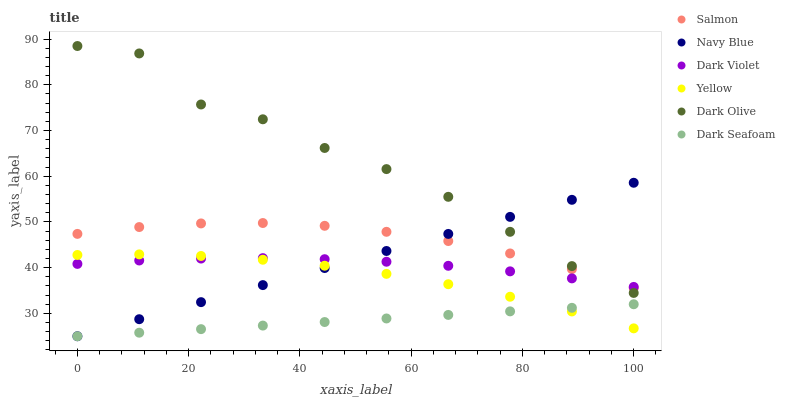Does Dark Seafoam have the minimum area under the curve?
Answer yes or no. Yes. Does Dark Olive have the maximum area under the curve?
Answer yes or no. Yes. Does Salmon have the minimum area under the curve?
Answer yes or no. No. Does Salmon have the maximum area under the curve?
Answer yes or no. No. Is Dark Seafoam the smoothest?
Answer yes or no. Yes. Is Dark Olive the roughest?
Answer yes or no. Yes. Is Salmon the smoothest?
Answer yes or no. No. Is Salmon the roughest?
Answer yes or no. No. Does Navy Blue have the lowest value?
Answer yes or no. Yes. Does Dark Olive have the lowest value?
Answer yes or no. No. Does Dark Olive have the highest value?
Answer yes or no. Yes. Does Salmon have the highest value?
Answer yes or no. No. Is Dark Seafoam less than Salmon?
Answer yes or no. Yes. Is Dark Olive greater than Yellow?
Answer yes or no. Yes. Does Navy Blue intersect Yellow?
Answer yes or no. Yes. Is Navy Blue less than Yellow?
Answer yes or no. No. Is Navy Blue greater than Yellow?
Answer yes or no. No. Does Dark Seafoam intersect Salmon?
Answer yes or no. No. 